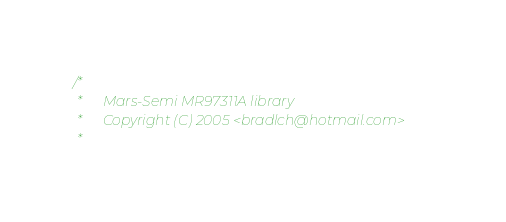<code> <loc_0><loc_0><loc_500><loc_500><_C_>/*
 *		Mars-Semi MR97311A library
 *		Copyright (C) 2005 <bradlch@hotmail.com>
 *</code> 